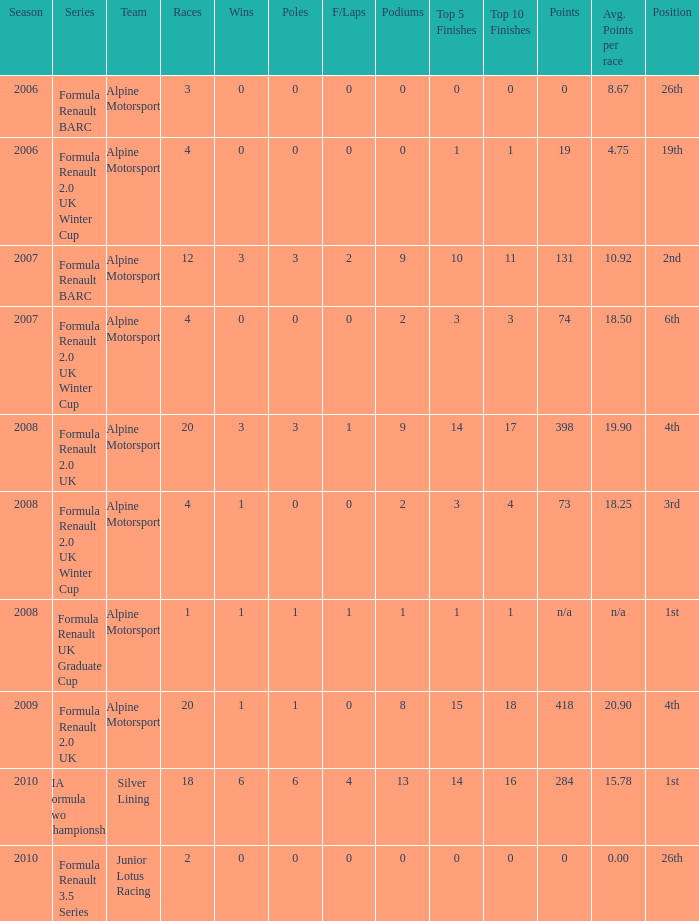What was the earliest season where podium was 9? 2007.0. 